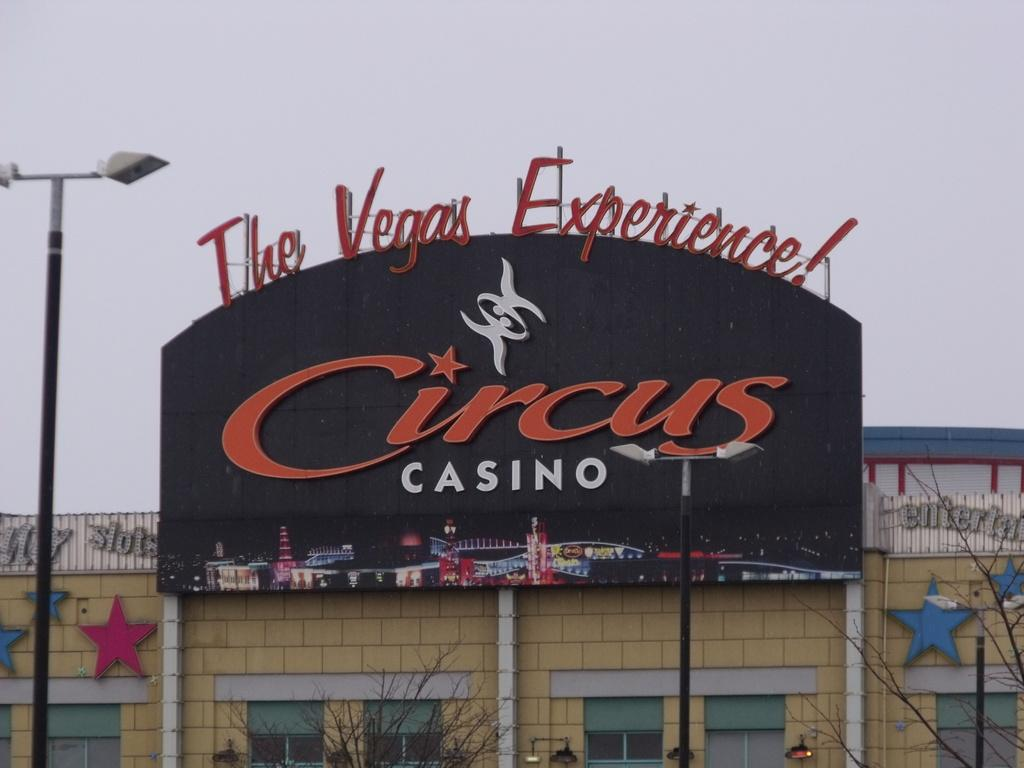What type of structure is present in the image? There is a building in the image. What is attached to the building? There is a board on the building. What can be seen on the board? There is an image and text written on the board. What other objects are visible in the image? There is a light pole and trees in the image. What can be seen in the background of the image? The sky is visible in the image. What type of prose is written on the board in the image? There is no prose present in the image; the board contains an image and text, but it is not specified as prose. 